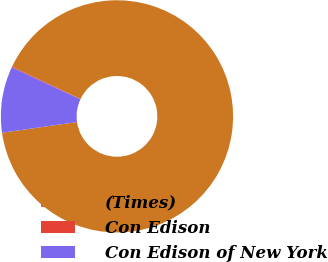Convert chart. <chart><loc_0><loc_0><loc_500><loc_500><pie_chart><fcel>(Times)<fcel>Con Edison<fcel>Con Edison of New York<nl><fcel>90.68%<fcel>0.13%<fcel>9.19%<nl></chart> 